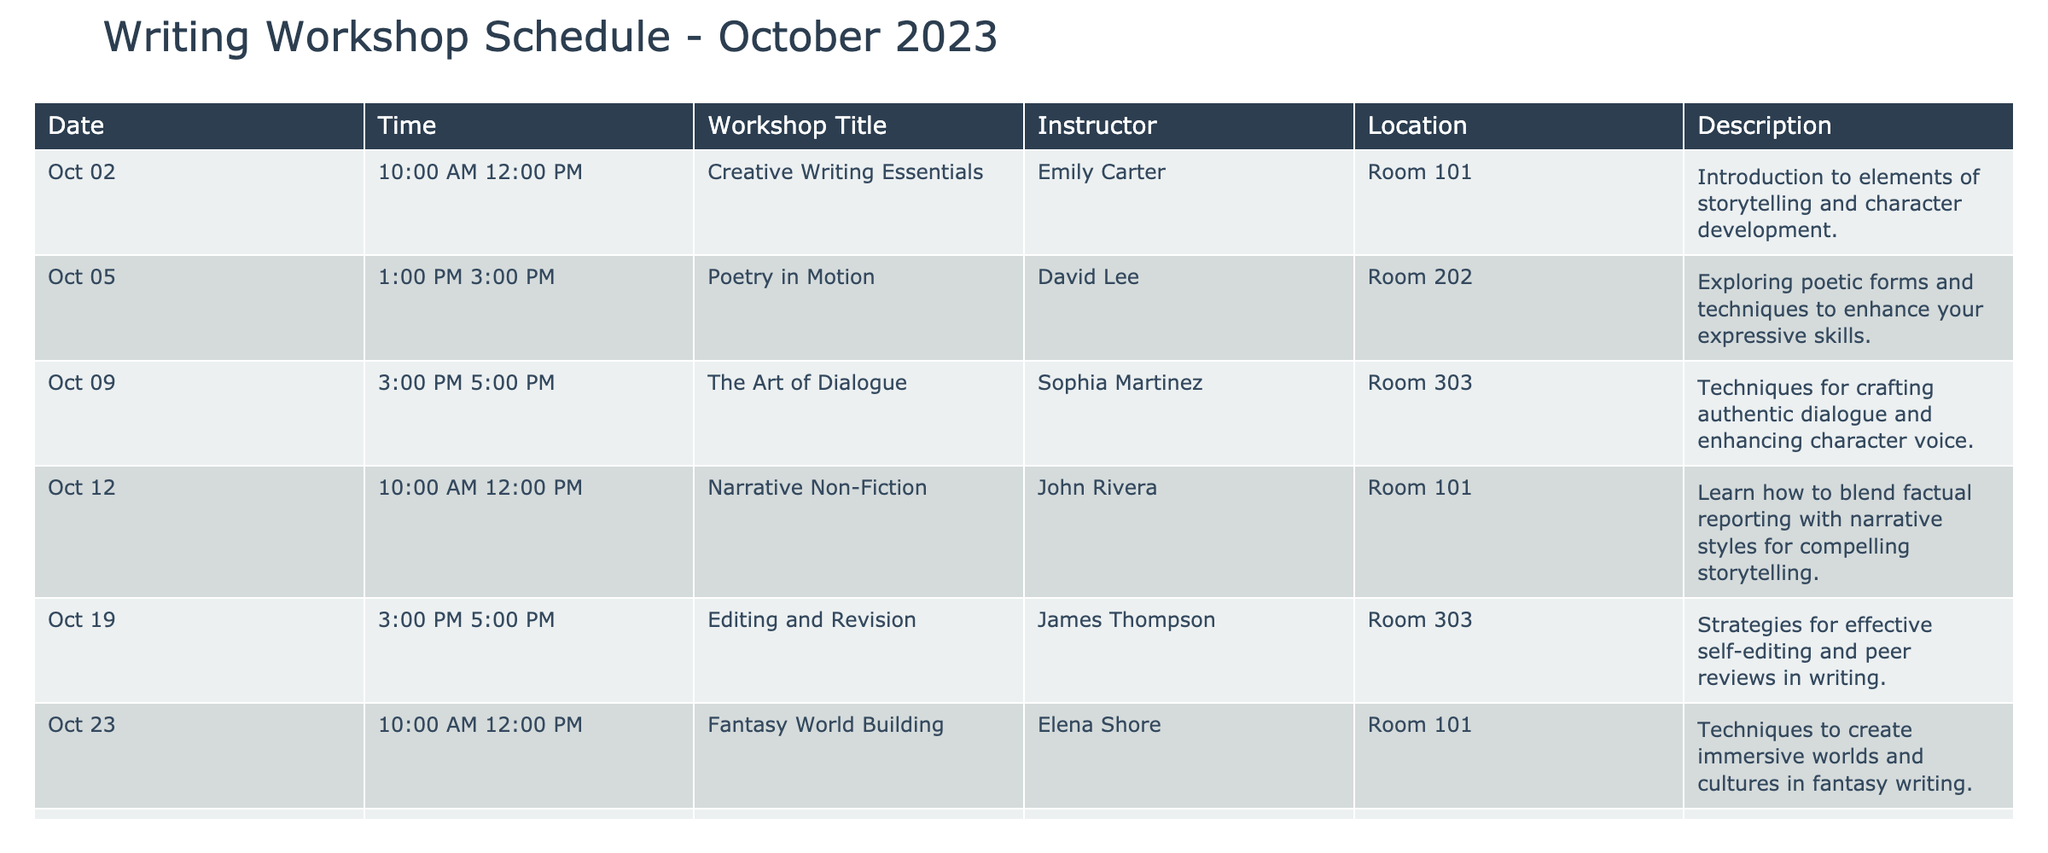What is the title of the workshop on October 5, 2023? The workshop on October 5, 2023, is titled "Poetry in Motion." This information can be directly retrieved from the 'Workshop Title' column that corresponds to the date in the table.
Answer: Poetry in Motion Who is instructing the "Editing and Revision" workshop? The instructor for the "Editing and Revision" workshop is James Thompson. This is found in the 'Instructor' column next to this specific workshop in the table.
Answer: James Thompson How many workshops are scheduled in total for October 2023? There are 6 workshops listed for the month of October 2023, which can be counted by reviewing the entries in the 'Date' column.
Answer: 6 Is there a workshop focused on character development? Yes, the "Creative Writing Essentials" workshop, which takes place on October 2, 2023, focuses on elements of storytelling and character development. This can be confirmed by checking the 'Description' for this specific title.
Answer: Yes What is the average start time of the workshops in the schedule? To find the average start time, we need to convert the start times of the workshops (10:00 AM, 1:00 PM, 3:00 PM) into a 24-hour format and calculate: 10:00 (10), 13:00 (13), and 15:00 (15). The sum is 10 + 13 + 15 + 10 + 15 + 13 = 76, and dividing that by 6 gives an average time of 12:40 PM. Thus, the final average time is around 12:40 PM when converted back to the 12-hour format.
Answer: 12:40 PM Which workshop takes place first in the month of October 2023? The first workshop is "Creative Writing Essentials," which is scheduled for October 2, 2023. This is determined by looking at the 'Date' column to find the earliest date listed.
Answer: Creative Writing Essentials How many workshops are held in Room 101? There are three workshops scheduled in Room 101. By examining the 'Location' column, we can count the entries where Room 101 is listed, specifically for the dates October 2, 12, and 23.
Answer: 3 Which instructor is associated with the most workshops in October 2023? Elena Shore and James Thompson are associated with one workshop each, while Emily Carter has one workshop. All other instructors teach only one workshop. Thus, no single instructor has more workshops than the others. Therefore, all instructors are balanced.
Answer: None Is the "Fantasy World Building" workshop offered on a weekend? No, "Fantasy World Building" is scheduled for October 23, 2023, which is a Monday. By referring to the 'Date' column and checking the day of the week for this date, we can confirm it is a weekday.
Answer: No 